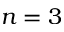<formula> <loc_0><loc_0><loc_500><loc_500>n = 3</formula> 